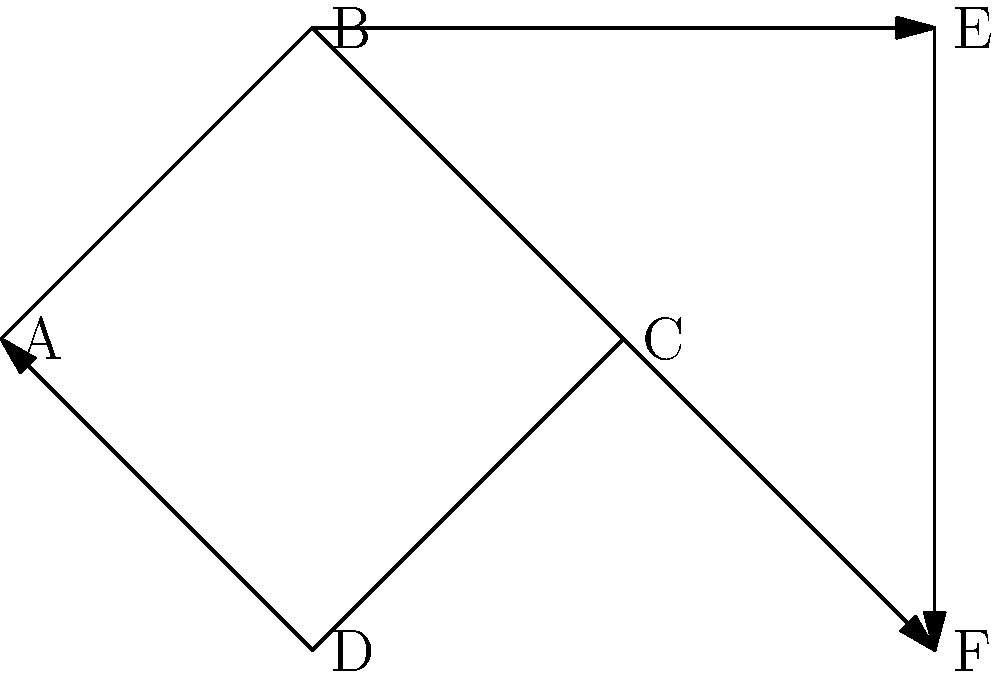As a travel blogger planning a series of tours, you want to avoid overcrowding at attractions. The graph represents possible tour routes between attractions A, B, C, D, E, and F. Edges indicate one-way paths, and you can't revisit an attraction. What's the maximum number of non-overlapping tours that can be scheduled simultaneously to minimize crowding? To solve this problem, we need to find the maximum number of edge-disjoint paths in the given directed graph. This can be done by following these steps:

1. Identify all possible paths from start to end:
   - A → B → E → F
   - A → B → C → F
   - A → D → C → F

2. Analyze the paths for edge overlap:
   - Path 1 and Path 2 share edge A → B
   - Path 2 and Path 3 share edge C → F

3. Determine the maximum number of non-overlapping paths:
   - We can choose Path 1 (A → B → E → F) and Path 3 (A → D → C → F)
   - These two paths don't share any edges, allowing for simultaneous tours

4. Consider the fishing trip experience:
   - As a travel blogger who had an unpleasant fishing experience, you might be more inclined to avoid water-based attractions. However, this doesn't affect the mathematical solution to the problem.

Therefore, the maximum number of non-overlapping tours that can be scheduled simultaneously is 2.
Answer: 2 